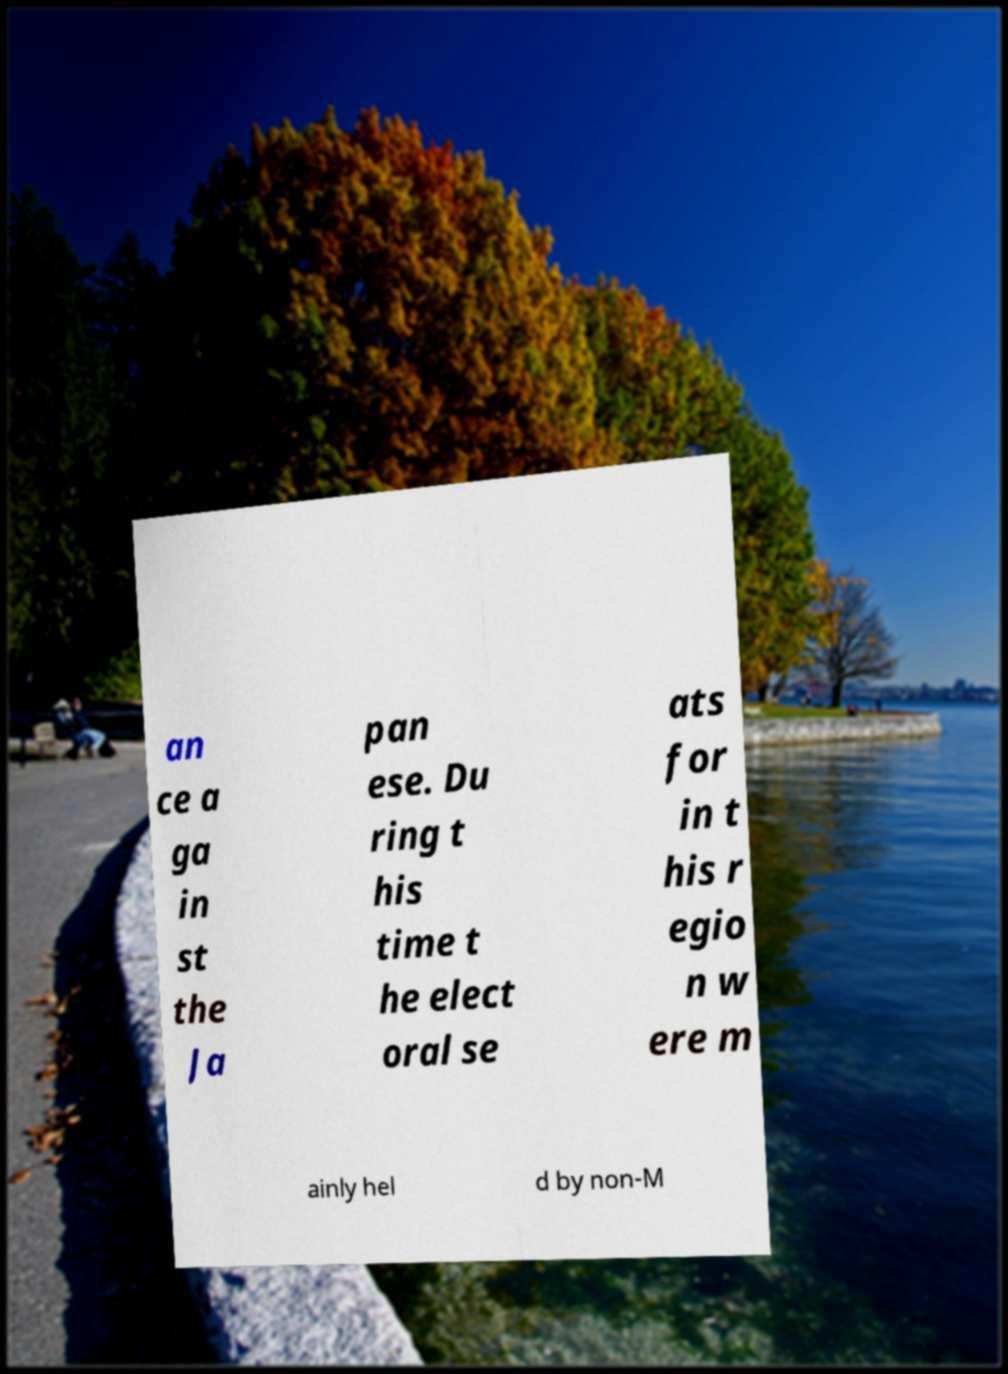Could you extract and type out the text from this image? an ce a ga in st the Ja pan ese. Du ring t his time t he elect oral se ats for in t his r egio n w ere m ainly hel d by non-M 